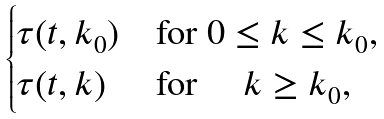<formula> <loc_0><loc_0><loc_500><loc_500>\begin{cases} \tau ( t , k _ { 0 } ) & \text {for $0 \leq k \leq k_{0}$} , \\ \tau ( t , k ) & \text {for $\quad k \geq k_{0}$,} \end{cases}</formula> 